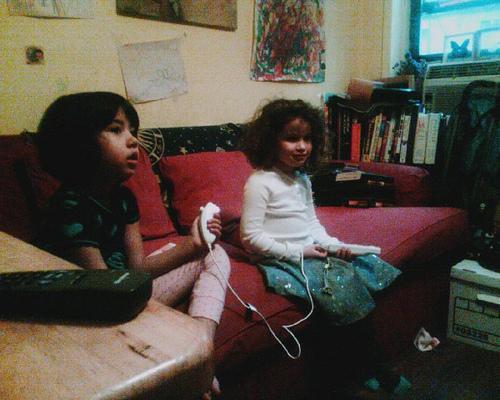What are the girls sitting on?
Answer briefly. Couch. Are the two peoples knees touching?
Give a very brief answer. No. What are the children's attention most likely directed at?
Short answer required. Tv. How many controllers are the girls sharing?
Quick response, please. 1. 